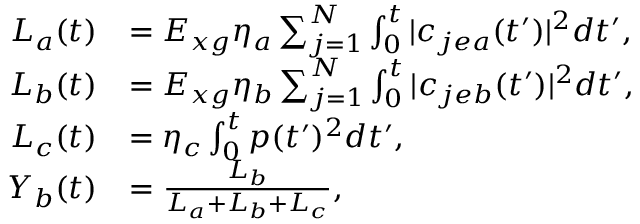<formula> <loc_0><loc_0><loc_500><loc_500>\begin{array} { r l } { L _ { a } ( t ) } & { = E _ { x g } \eta _ { a } \sum _ { j = 1 } ^ { N } \int _ { 0 } ^ { t } | c _ { j e a } ( t ^ { \prime } ) | ^ { 2 } d t ^ { \prime } , } \\ { L _ { b } ( t ) } & { = E _ { x g } \eta _ { b } \sum _ { j = 1 } ^ { N } \int _ { 0 } ^ { t } | c _ { j e b } ( t ^ { \prime } ) | ^ { 2 } d t ^ { \prime } , } \\ { L _ { c } ( t ) } & { = \eta _ { c } \int _ { 0 } ^ { t } p ( t ^ { \prime } ) ^ { 2 } d t ^ { \prime } , } \\ { Y _ { b } ( t ) } & { = \frac { L _ { b } } { L _ { a } + L _ { b } + L _ { c } } , } \end{array}</formula> 